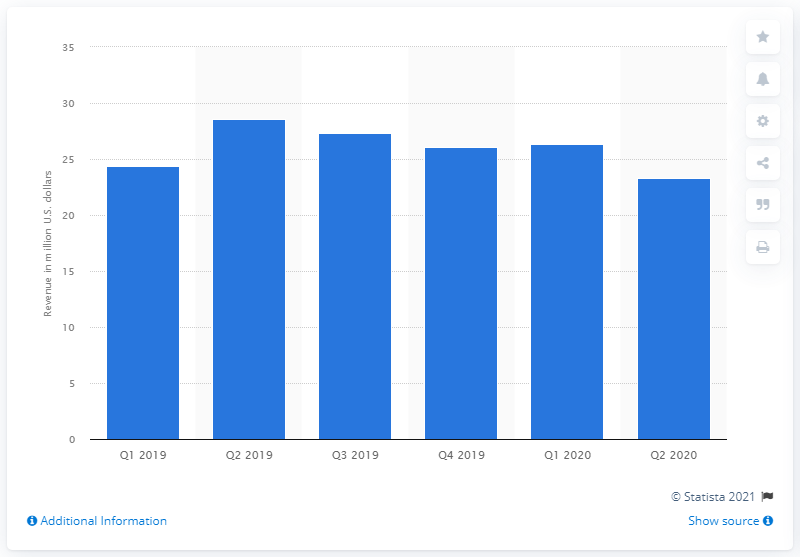Draw attention to some important aspects in this diagram. In the second quarter of 2020, Napster generated $23.34 million in revenue. Napster's revenue decreased by 23.34% from the beginning of 2020. 